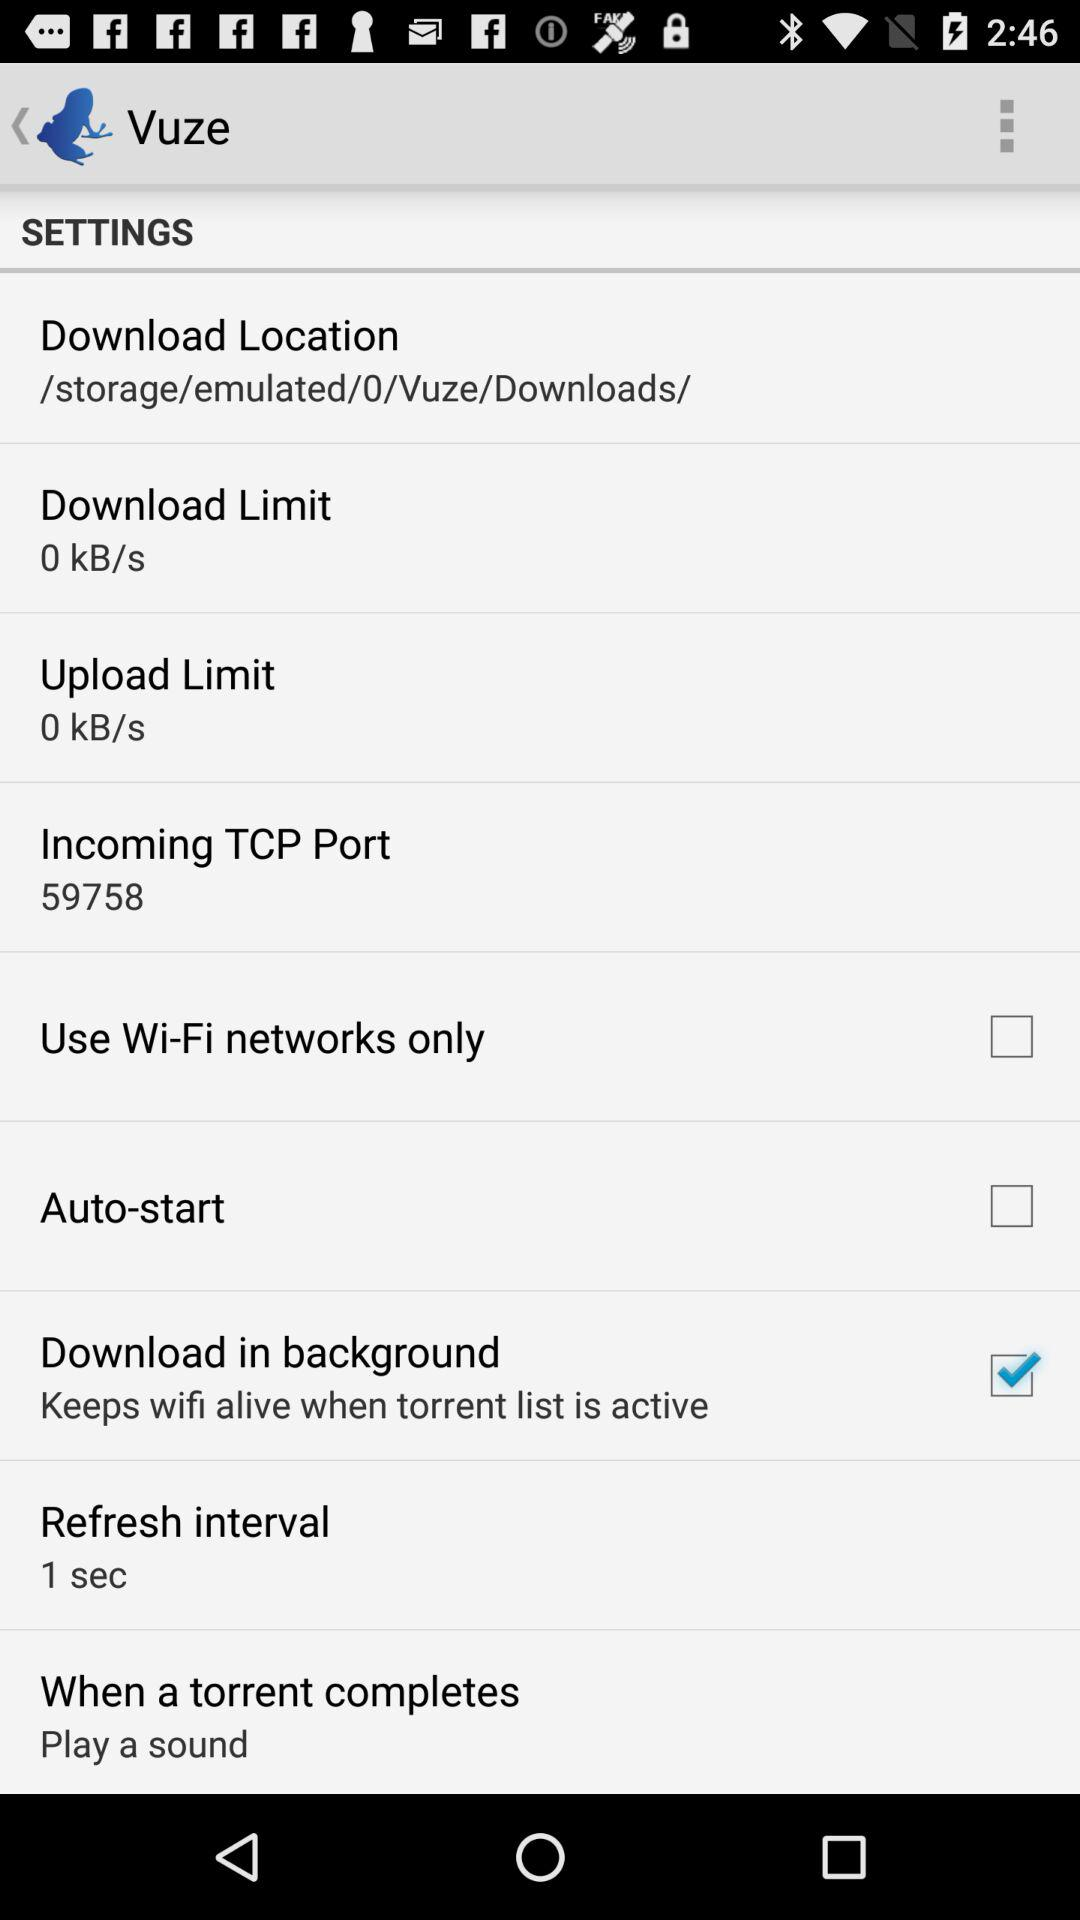What is the upload limit? The upload limit is 0 kB/s. 